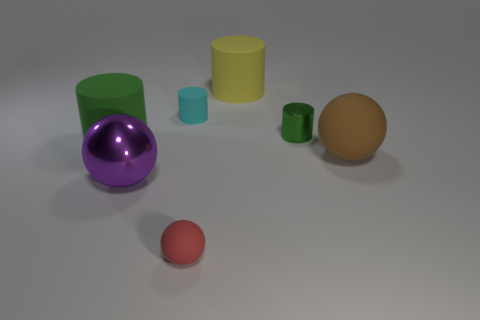Subtract 1 cylinders. How many cylinders are left? 3 Add 3 small cyan cylinders. How many objects exist? 10 Subtract all cylinders. How many objects are left? 3 Add 6 tiny metallic objects. How many tiny metallic objects are left? 7 Add 6 small purple balls. How many small purple balls exist? 6 Subtract 2 green cylinders. How many objects are left? 5 Subtract all green rubber objects. Subtract all small purple things. How many objects are left? 6 